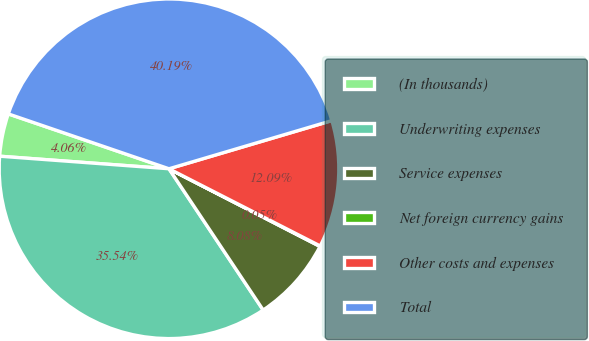<chart> <loc_0><loc_0><loc_500><loc_500><pie_chart><fcel>(In thousands)<fcel>Underwriting expenses<fcel>Service expenses<fcel>Net foreign currency gains<fcel>Other costs and expenses<fcel>Total<nl><fcel>4.06%<fcel>35.54%<fcel>8.08%<fcel>0.05%<fcel>12.09%<fcel>40.19%<nl></chart> 